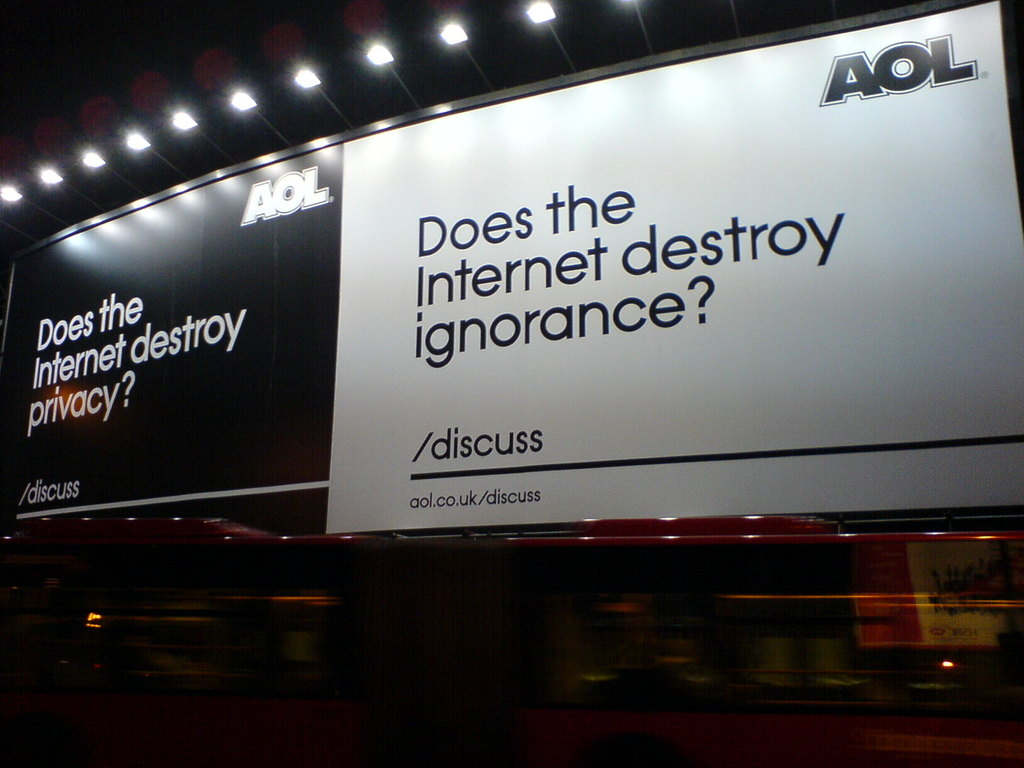Can this advertisement by AOL be seen as a social commentary? Yes, this AOL advertisement serves as a form of social commentary by prompting viewers to reflect on complex issues regarding the Internet's role in society. By posing questions about privacy and ignorance in such a public and visually striking manner, the ad encourages discourse on critical issues that affect modern life, reflecting on the dual capacity of the Internet to empower and to invade. 